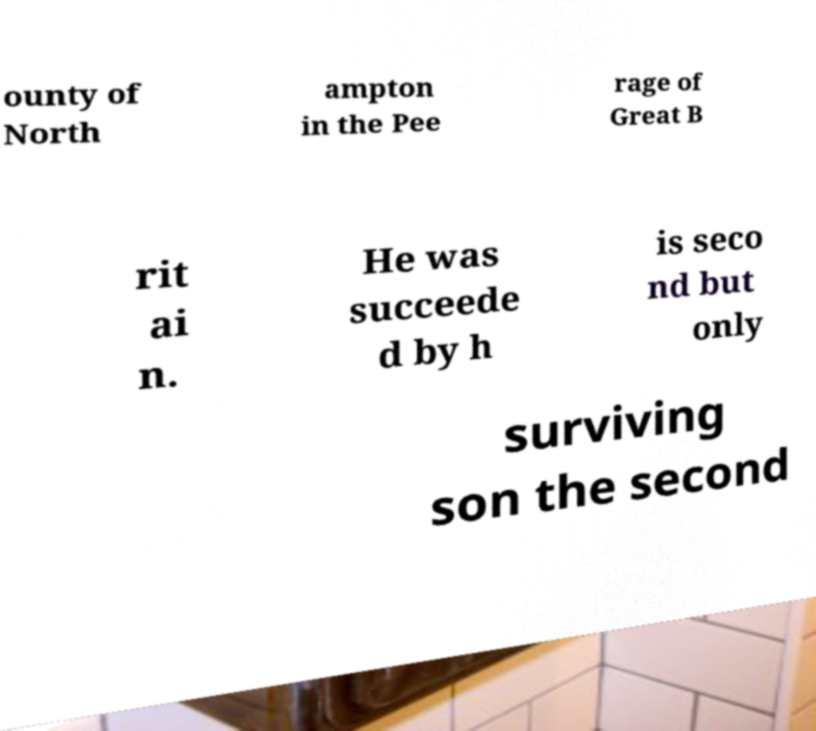Could you extract and type out the text from this image? ounty of North ampton in the Pee rage of Great B rit ai n. He was succeede d by h is seco nd but only surviving son the second 